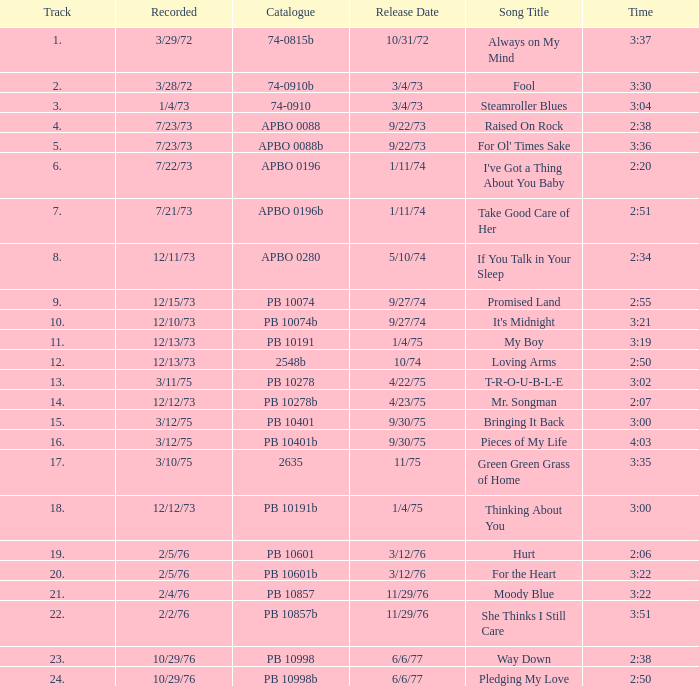Indicate the 6/6/77 release date's time and the name of the song way down. 2:38. 